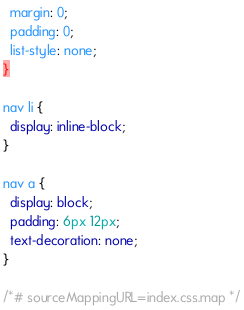<code> <loc_0><loc_0><loc_500><loc_500><_CSS_>  margin: 0;
  padding: 0;
  list-style: none;
}

nav li {
  display: inline-block;
}

nav a {
  display: block;
  padding: 6px 12px;
  text-decoration: none;
}

/*# sourceMappingURL=index.css.map */
</code> 